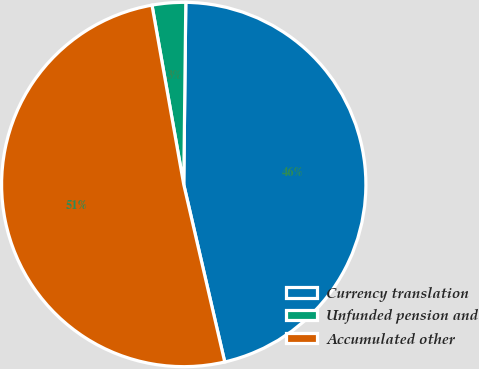Convert chart. <chart><loc_0><loc_0><loc_500><loc_500><pie_chart><fcel>Currency translation<fcel>Unfunded pension and<fcel>Accumulated other<nl><fcel>46.21%<fcel>2.97%<fcel>50.83%<nl></chart> 